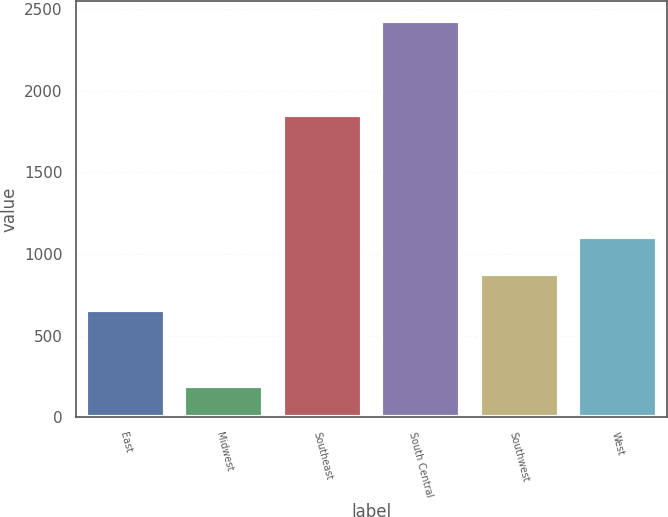Convert chart to OTSL. <chart><loc_0><loc_0><loc_500><loc_500><bar_chart><fcel>East<fcel>Midwest<fcel>Southeast<fcel>South Central<fcel>Southwest<fcel>West<nl><fcel>655<fcel>192<fcel>1851<fcel>2426<fcel>878.4<fcel>1101.8<nl></chart> 